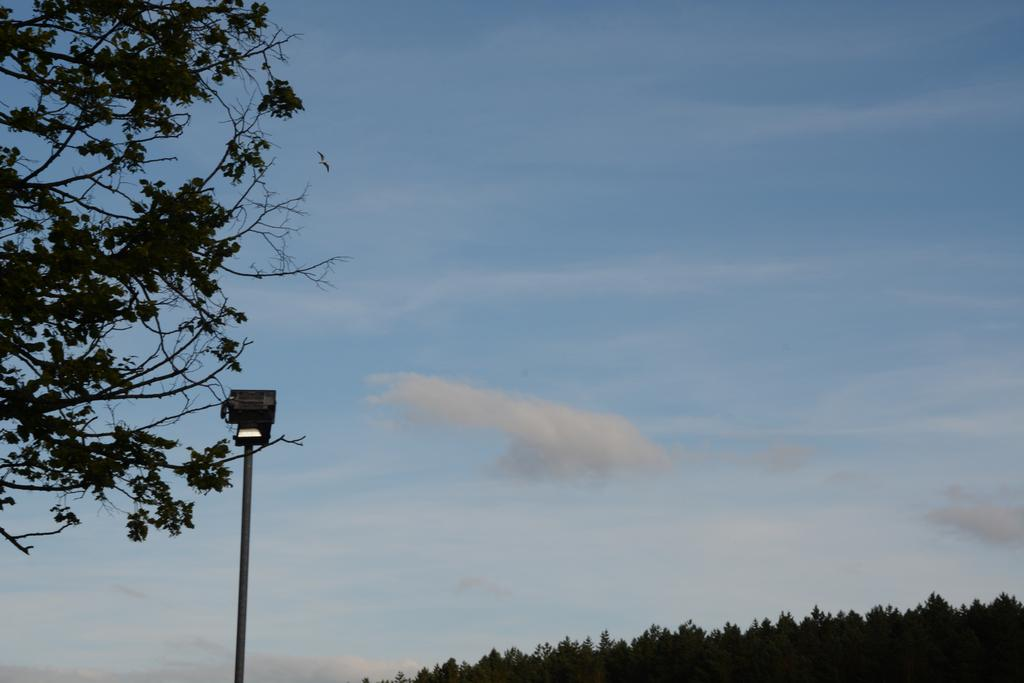What is located in the foreground of the image? There is a light placed on a pole in the foreground of the image. What can be seen in the background of the image? A bird is flying in the sky, and there is a group of trees in the background of the image. How would you describe the sky in the image? The sky is cloudy in the background of the image. What type of pancake is the carpenter eating while experiencing a thrill in the image? There is no carpenter, pancake, or thrill present in the image. 